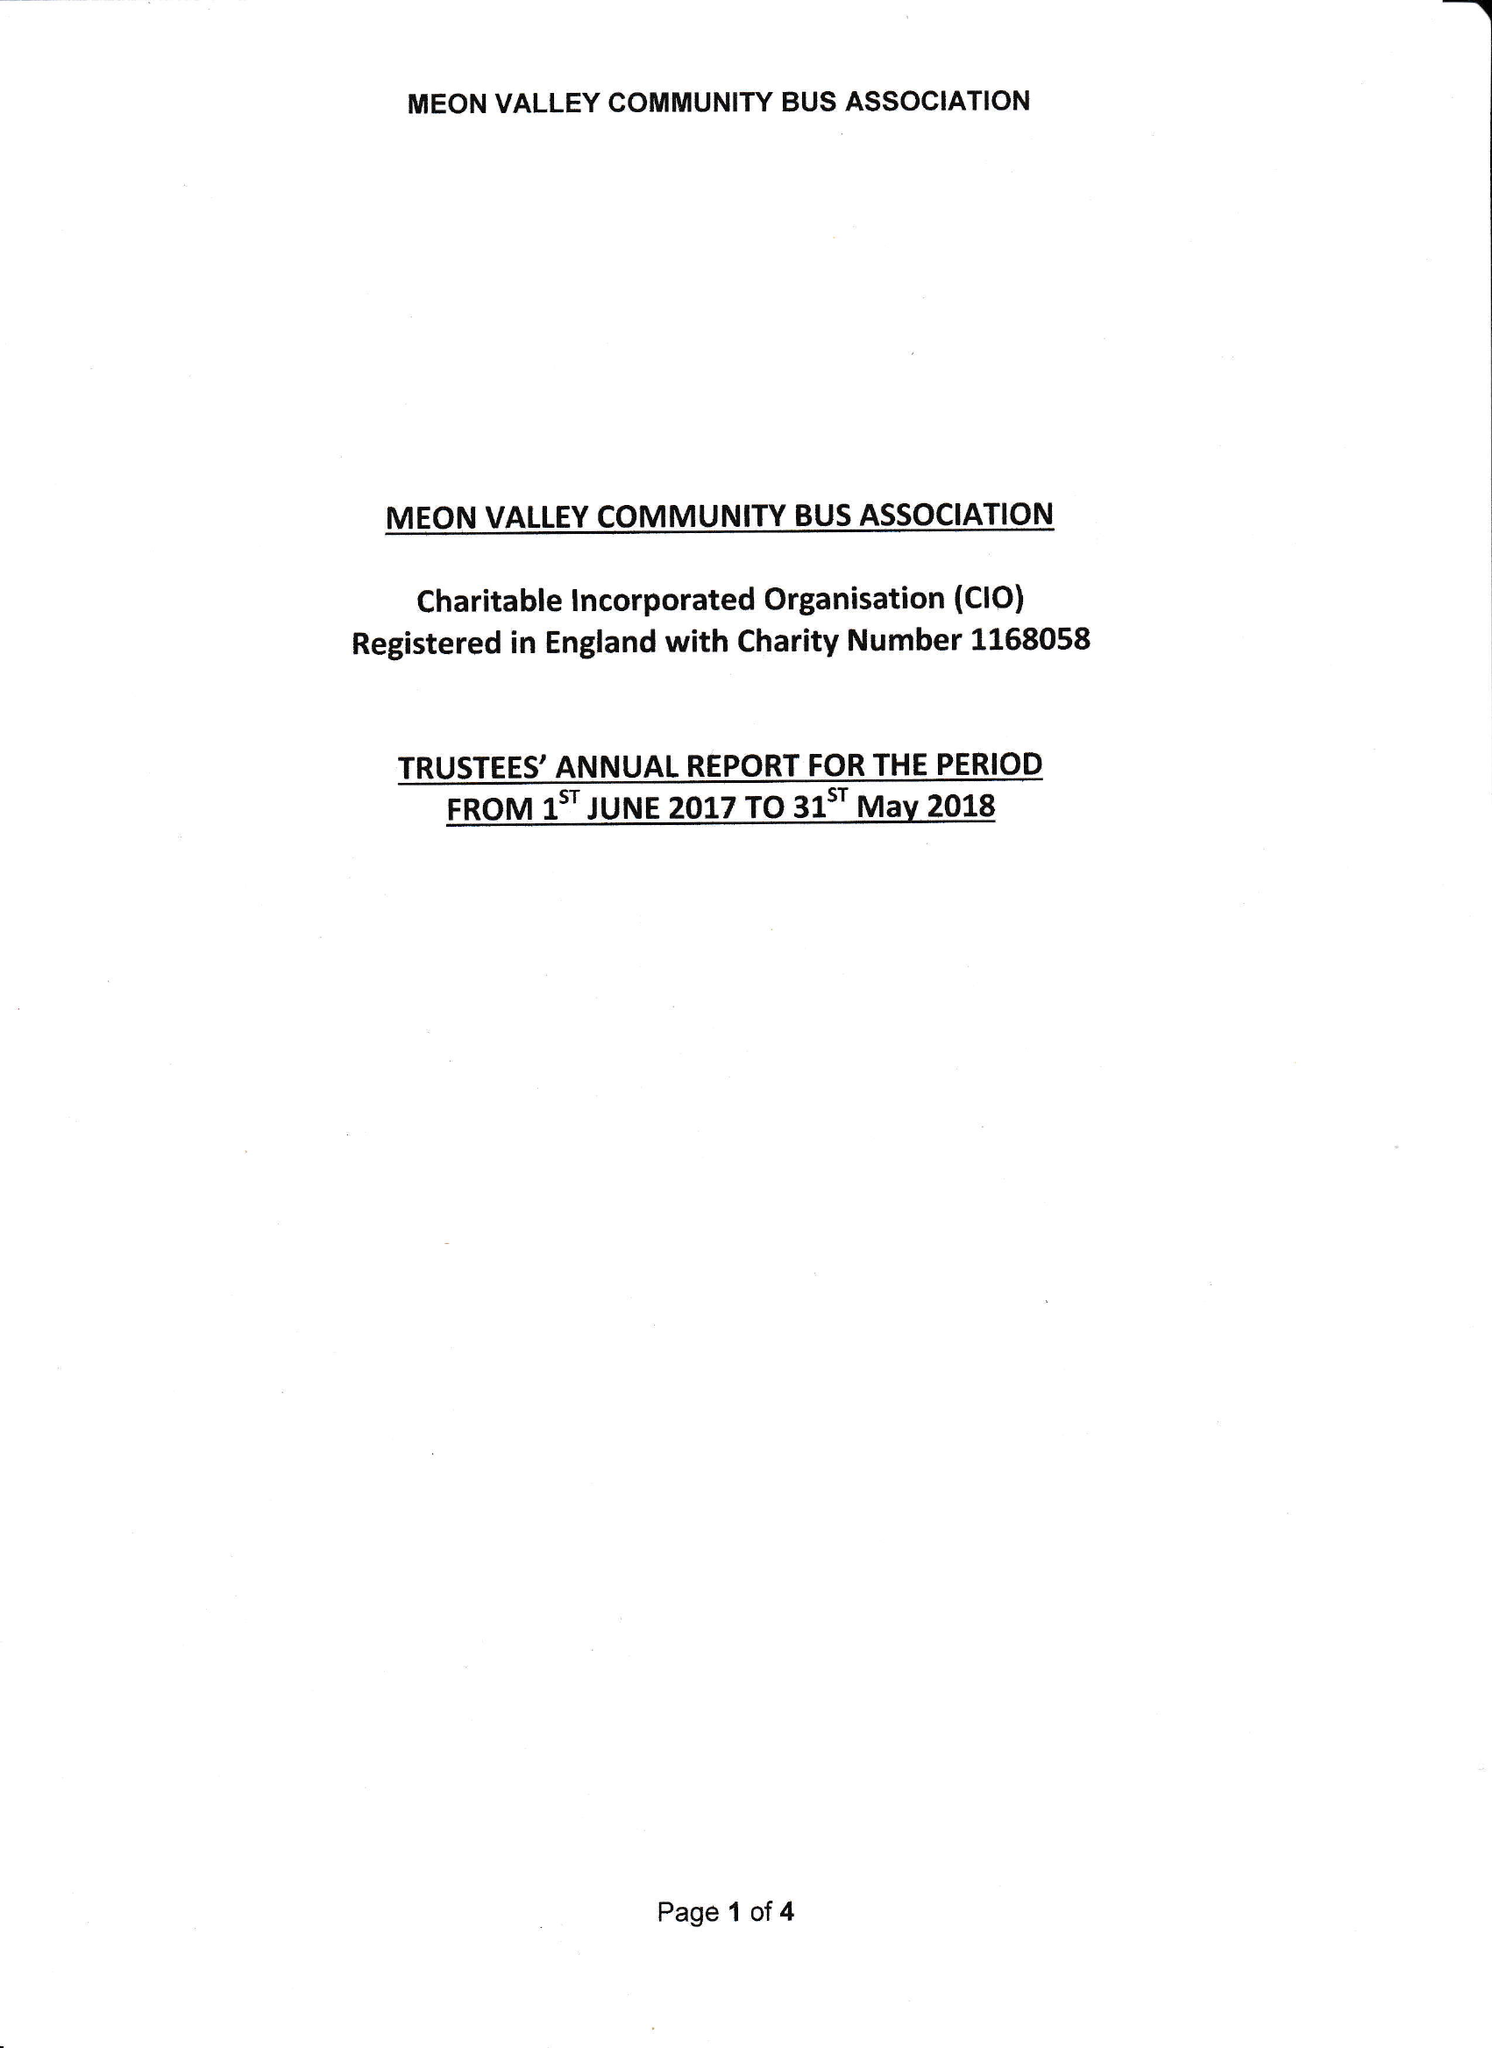What is the value for the report_date?
Answer the question using a single word or phrase. 2018-05-31 